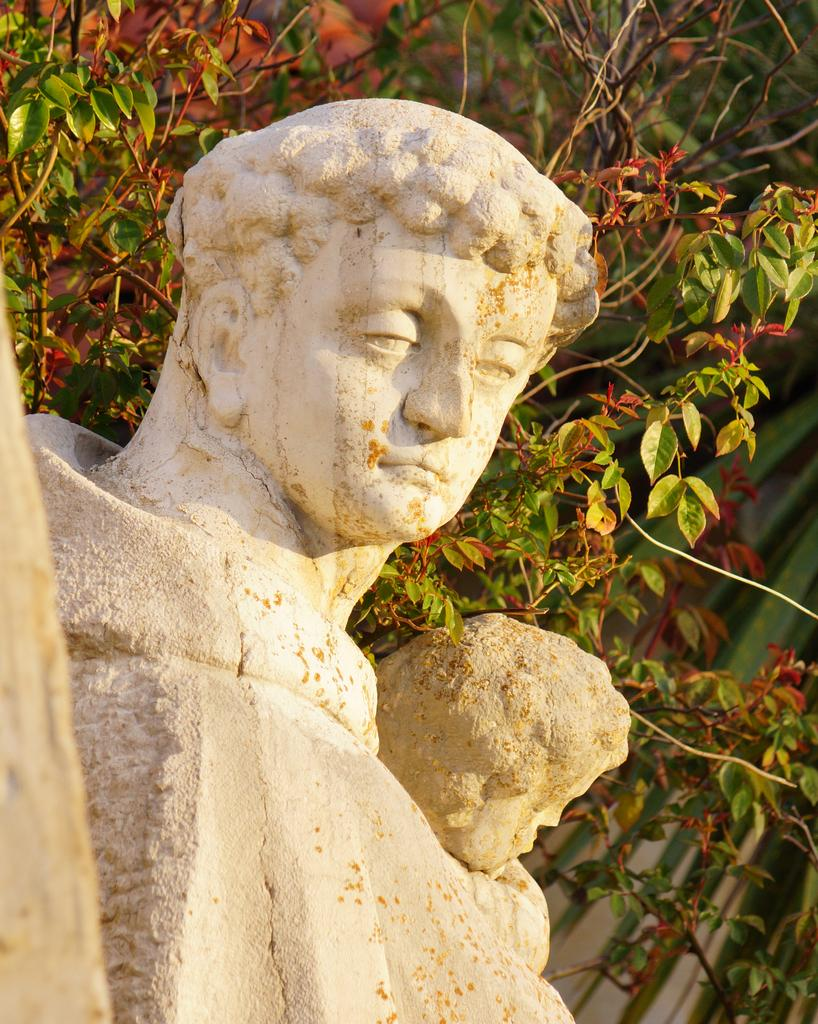What type of objects can be seen in the image? There are statues in the image. What other elements can be found in the image? There are trees in the image. What joke is the governor telling near the statues in the image? There is no governor or joke present in the image; it only features statues and trees. 